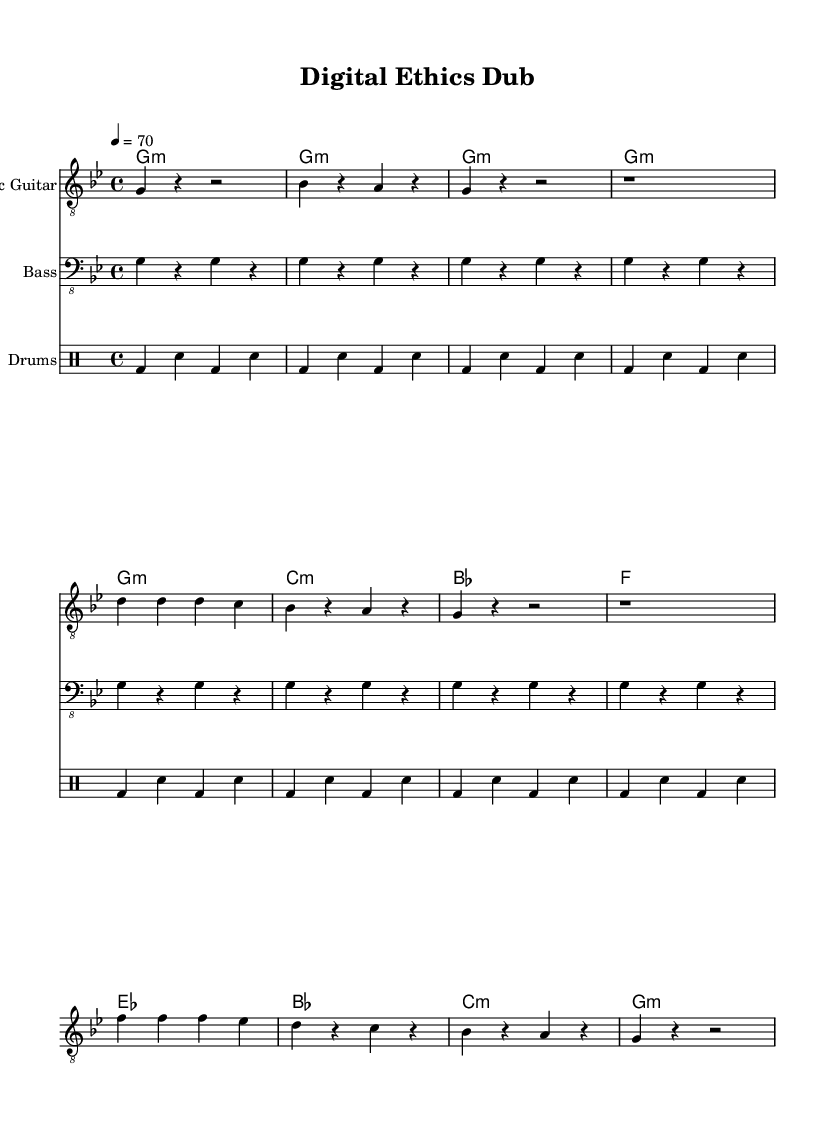What is the key signature of this music? The key signature is G minor, which has two flats (B♭ and E♭). This can be determined by observing the key signature indicated at the beginning of the score.
Answer: G minor What is the time signature of this music? The time signature is 4/4, as indicated at the beginning of the score. This means there are four beats in each measure and the quarter note receives one beat.
Answer: 4/4 What is the tempo marking of this music? The tempo marking is 70 beats per minute, which is noted in the score as "4 = 70". This indicates the speed at which the music should be played.
Answer: 70 How many measures are in the verse section? There are 8 measures in the verse section, which can be verified by counting the measures from the start of the verse until the end of the provided segment.
Answer: 8 What type of musical structure is primarily used in reggae based on the score? The score primarily includes a repetitive structure, seen in the bass and drums parts, characteristic of reggae music, which often emphasizes laid-back rhythms and groove.
Answer: Repetitive structure What is the main chord used in the chorus section? The main chord used in the chorus section is E♭ major, which is found in the part designated for the chorus in the chords line.
Answer: E♭ major How does the drum pattern contribute to the reggae feel of the piece? The drum pattern features a consistent kick and snare alternating rhythm, which creates the "one drop" feel common in reggae music, underscoring the laid-back groove throughout the piece.
Answer: One drop feel 